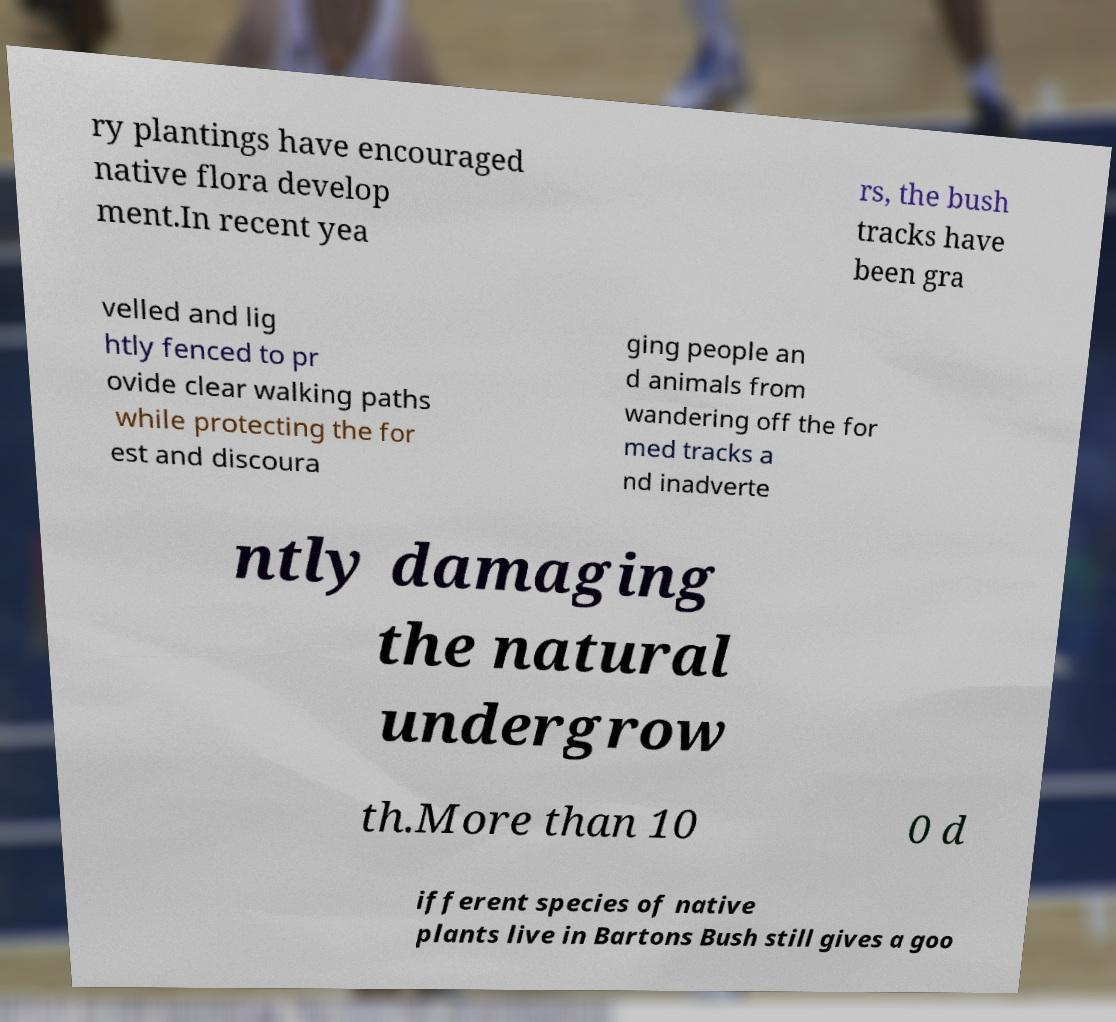Can you accurately transcribe the text from the provided image for me? ry plantings have encouraged native flora develop ment.In recent yea rs, the bush tracks have been gra velled and lig htly fenced to pr ovide clear walking paths while protecting the for est and discoura ging people an d animals from wandering off the for med tracks a nd inadverte ntly damaging the natural undergrow th.More than 10 0 d ifferent species of native plants live in Bartons Bush still gives a goo 